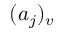Convert formula to latex. <formula><loc_0><loc_0><loc_500><loc_500>( a _ { j } ) _ { v }</formula> 